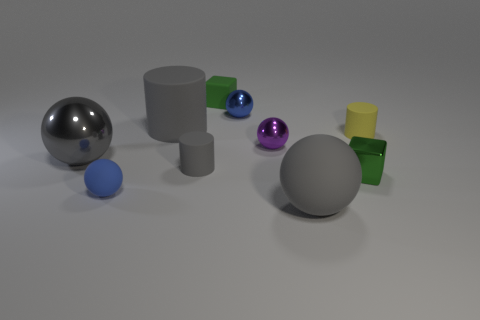There is a large object that is in front of the small matte ball; is it the same color as the tiny rubber thing that is to the right of the small purple metal sphere?
Ensure brevity in your answer.  No. The yellow rubber object that is the same size as the green rubber thing is what shape?
Provide a short and direct response. Cylinder. What number of things are either tiny metal spheres in front of the blue metallic thing or tiny spheres that are behind the tiny green shiny block?
Ensure brevity in your answer.  2. Is the number of blue matte things less than the number of small brown rubber things?
Ensure brevity in your answer.  No. There is a purple object that is the same size as the green rubber object; what material is it?
Make the answer very short. Metal. There is a blue thing behind the small gray cylinder; does it have the same size as the blue ball in front of the purple metallic sphere?
Provide a succinct answer. Yes. Is there a large thing that has the same material as the small yellow thing?
Your response must be concise. Yes. How many things are either rubber cylinders that are on the right side of the small purple shiny object or small brown rubber things?
Your response must be concise. 1. Does the gray sphere that is right of the gray shiny object have the same material as the small yellow cylinder?
Give a very brief answer. Yes. Does the tiny yellow thing have the same shape as the gray shiny thing?
Your answer should be very brief. No. 